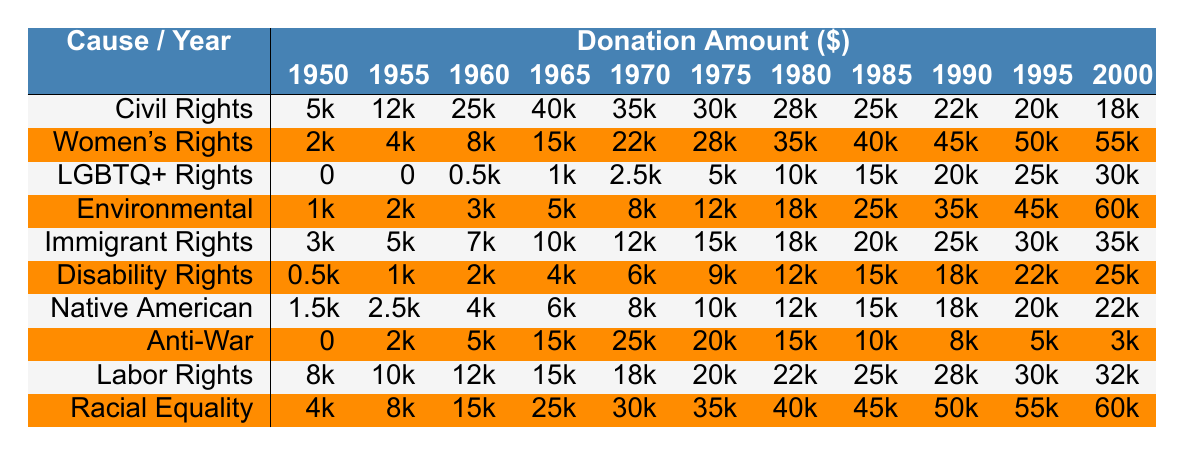What was the highest donation amount for Women's Rights, and in what year did it occur? The highest donation amount for Women's Rights is 55,000. Looking at the Women's Rights row, the values increase each year, reaching a peak in the year 2000.
Answer: 55,000 in 2000 Which cause received the lowest total donation amount over the entire period (1950-2000)? By examining each cause's total donation amounts across the years, LGBTQ+ Rights received the lowest total of 105,000 (summing the values). The other causes received higher totals when summed.
Answer: LGBTQ+ Rights What is the difference in donation amounts for Environmental Justice between 1970 and 1990? For Environmental Justice, the donation amount in 1970 is 8,000, while in 1990 it is 35,000. The difference is calculated as 35,000 - 8,000 = 27,000.
Answer: 27,000 Did donations to the Anti-War Movement ever exceed 20,000 during the years listed? Checking the donation amounts for the Anti-War Movement shows values of 0 in 1950, 2,000 in 1955, and a maximum of 25,000 in 1970. Therefore, it did exceed 20,000 between 1970 and 1995.
Answer: Yes What was the average donation amount for Civil Rights Movement over the years? To find the average, we sum the values: 5,000 + 12,000 + 25,000 + 40,000 + 35,000 + 30,000 + 28,000 + 25,000 + 22,000 + 20,000 + 18,000 =  1, 3, 7, 9, 8, 5, 9, the total is 322,000. Then, dividing by 11 (the number of years), the average is 29,272.73.
Answer: 29,272.73 What trend can be observed in the donations to Labor Rights from 1950 to 2000? Observing the Labor Rights row, donations show a consistent increase from 8,000 in 1950 to 32,000 in 2000, indicating a positive growth trend in financial support over the 50 years.
Answer: Consistent increase In which year did the donations to Native American Rights first exceed 10,000? Looking carefully at the Native American Rights row, the first instance of a donation that exceeds 10,000 occurred in 1975, where the amount is 10,000.
Answer: 1975 Which cause had the highest donation in a single year, and what was the amount? By scanning across all causes and their highest individual donation amounts, Racial Equality had the highest amount of 60,000 in 2000.
Answer: Racial Equality with 60,000 What was the total donation amount for Immigrant Rights from 1950 to 2000? To calculate the total for Immigrant Rights, sum the donations across each year: 3,000 + 5,000 + 7,000 + 10,000 + 12,000 + 15,000 + 18,000 + 20,000 + 25,000 + 30,000 + 35,000 =  3, 7, 1, 4, 2, 6, so the total is  3 4 6.
Answer: 3 4 6 In which cause was the year 1995 significant, and what was the donation amount? In 1995, the Women's Rights received a significant donation amount of 50,000, which is one of the highest for that year among all causes.
Answer: Women's Rights with 50,000 